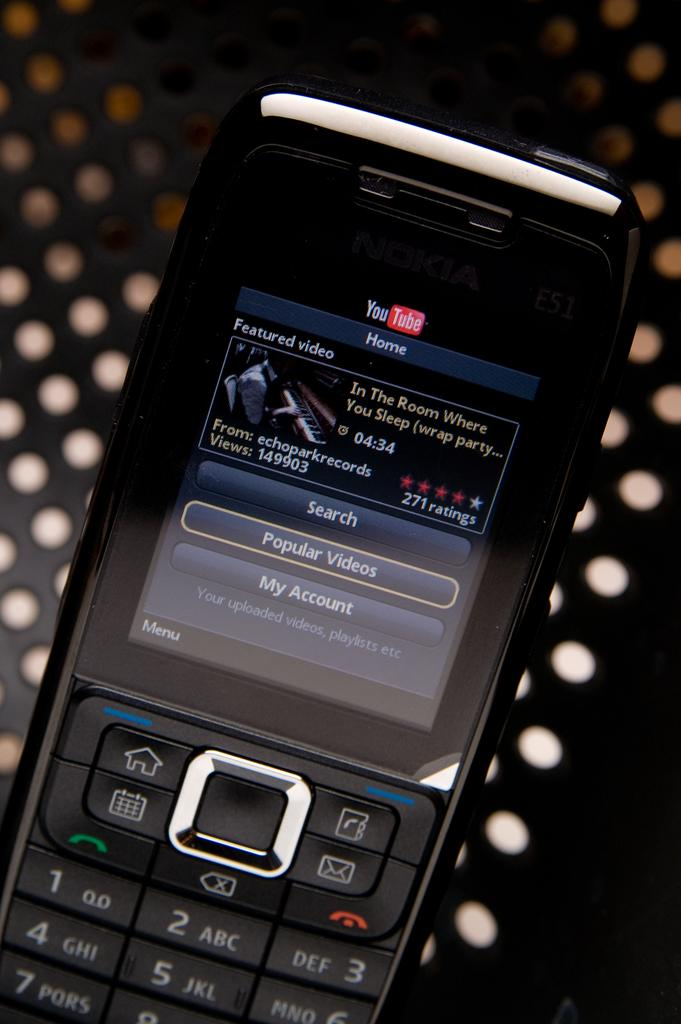What electronic device is present in the image? There is a mobile phone in the image. What is the mobile phone resting on? The mobile phone is on a metal object. What can be seen on the mobile phone screen? There is text visible on the mobile phone screen. What type of star can be seen shining brightly in the image? There is no star visible in the image; it features a mobile phone on a metal object with text on its screen. 